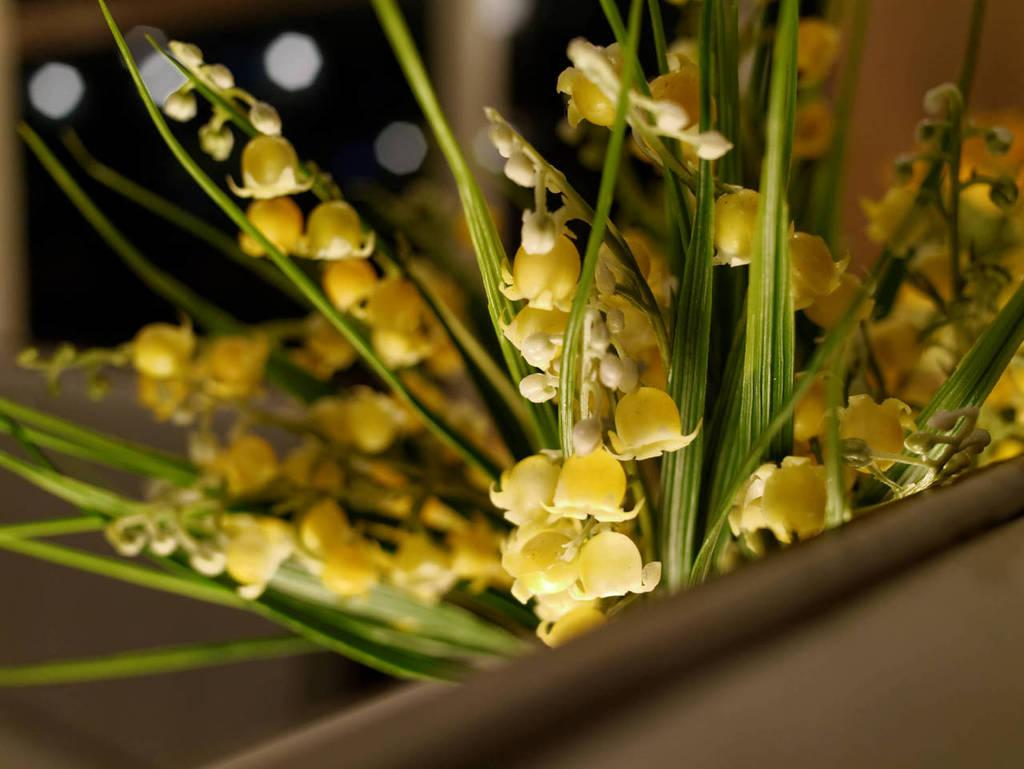What types of living organisms can be seen in the image? Plants and flowers are visible in the image. What is the background of the image like? The background of the image is blurred. Can you describe the object in the bottom right corner of the image? Unfortunately, the facts provided do not give any information about the object in the bottom right corner of the image. What type of park can be seen in the image? There is no park present in the image; it features plants and flowers. What is inside the box in the image? There is no box present in the image. 